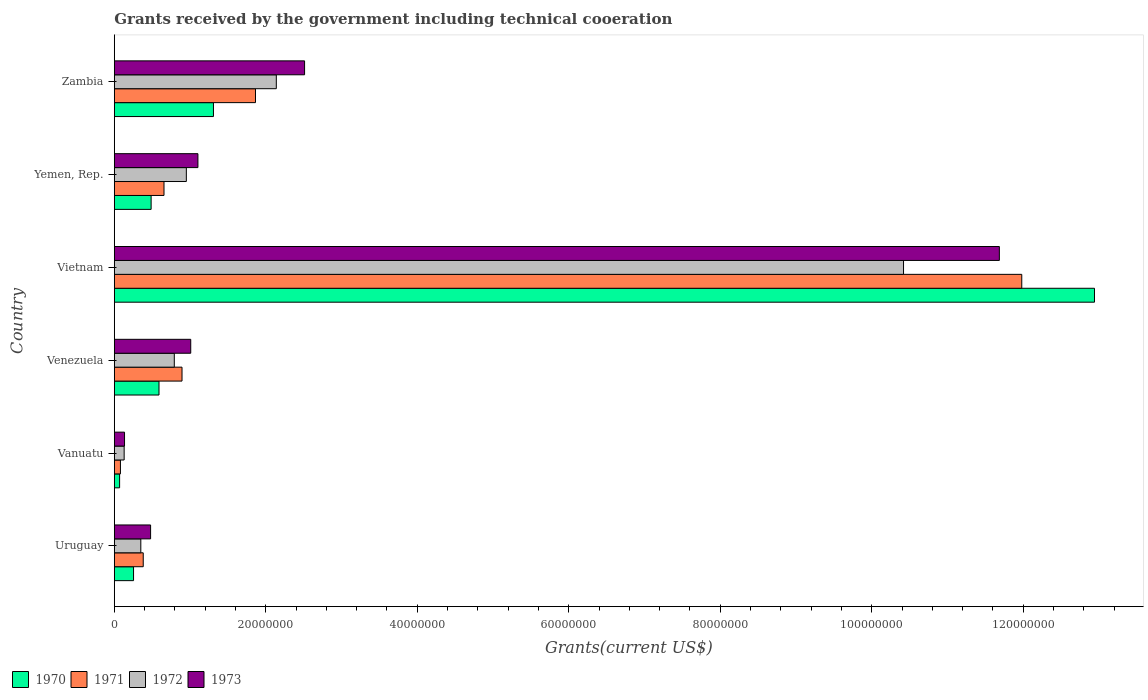How many groups of bars are there?
Your answer should be compact. 6. Are the number of bars per tick equal to the number of legend labels?
Offer a very short reply. Yes. What is the label of the 5th group of bars from the top?
Offer a terse response. Vanuatu. In how many cases, is the number of bars for a given country not equal to the number of legend labels?
Offer a very short reply. 0. What is the total grants received by the government in 1970 in Vanuatu?
Ensure brevity in your answer.  7.00e+05. Across all countries, what is the maximum total grants received by the government in 1973?
Provide a succinct answer. 1.17e+08. Across all countries, what is the minimum total grants received by the government in 1971?
Keep it short and to the point. 8.10e+05. In which country was the total grants received by the government in 1973 maximum?
Your answer should be very brief. Vietnam. In which country was the total grants received by the government in 1972 minimum?
Give a very brief answer. Vanuatu. What is the total total grants received by the government in 1973 in the graph?
Offer a terse response. 1.69e+08. What is the difference between the total grants received by the government in 1973 in Venezuela and that in Zambia?
Your response must be concise. -1.50e+07. What is the difference between the total grants received by the government in 1972 in Yemen, Rep. and the total grants received by the government in 1970 in Uruguay?
Your answer should be compact. 6.97e+06. What is the average total grants received by the government in 1970 per country?
Provide a short and direct response. 2.61e+07. What is the difference between the total grants received by the government in 1973 and total grants received by the government in 1970 in Zambia?
Ensure brevity in your answer.  1.20e+07. What is the ratio of the total grants received by the government in 1970 in Uruguay to that in Venezuela?
Offer a very short reply. 0.43. Is the total grants received by the government in 1970 in Vietnam less than that in Yemen, Rep.?
Give a very brief answer. No. What is the difference between the highest and the second highest total grants received by the government in 1970?
Your answer should be compact. 1.16e+08. What is the difference between the highest and the lowest total grants received by the government in 1972?
Provide a succinct answer. 1.03e+08. In how many countries, is the total grants received by the government in 1972 greater than the average total grants received by the government in 1972 taken over all countries?
Offer a very short reply. 1. Is it the case that in every country, the sum of the total grants received by the government in 1971 and total grants received by the government in 1972 is greater than the sum of total grants received by the government in 1970 and total grants received by the government in 1973?
Keep it short and to the point. No. What does the 2nd bar from the bottom in Yemen, Rep. represents?
Your response must be concise. 1971. Is it the case that in every country, the sum of the total grants received by the government in 1972 and total grants received by the government in 1971 is greater than the total grants received by the government in 1970?
Give a very brief answer. Yes. Are all the bars in the graph horizontal?
Your answer should be compact. Yes. How many countries are there in the graph?
Offer a terse response. 6. What is the difference between two consecutive major ticks on the X-axis?
Offer a terse response. 2.00e+07. Are the values on the major ticks of X-axis written in scientific E-notation?
Provide a succinct answer. No. Does the graph contain grids?
Keep it short and to the point. No. What is the title of the graph?
Ensure brevity in your answer.  Grants received by the government including technical cooeration. Does "2007" appear as one of the legend labels in the graph?
Provide a short and direct response. No. What is the label or title of the X-axis?
Make the answer very short. Grants(current US$). What is the Grants(current US$) in 1970 in Uruguay?
Your answer should be very brief. 2.54e+06. What is the Grants(current US$) of 1971 in Uruguay?
Provide a succinct answer. 3.82e+06. What is the Grants(current US$) in 1972 in Uruguay?
Your answer should be very brief. 3.50e+06. What is the Grants(current US$) in 1973 in Uruguay?
Provide a short and direct response. 4.79e+06. What is the Grants(current US$) in 1970 in Vanuatu?
Your answer should be compact. 7.00e+05. What is the Grants(current US$) of 1971 in Vanuatu?
Provide a succinct answer. 8.10e+05. What is the Grants(current US$) in 1972 in Vanuatu?
Your answer should be compact. 1.30e+06. What is the Grants(current US$) in 1973 in Vanuatu?
Give a very brief answer. 1.35e+06. What is the Grants(current US$) of 1970 in Venezuela?
Keep it short and to the point. 5.90e+06. What is the Grants(current US$) of 1971 in Venezuela?
Give a very brief answer. 8.94e+06. What is the Grants(current US$) of 1972 in Venezuela?
Keep it short and to the point. 7.92e+06. What is the Grants(current US$) in 1973 in Venezuela?
Offer a terse response. 1.01e+07. What is the Grants(current US$) of 1970 in Vietnam?
Keep it short and to the point. 1.29e+08. What is the Grants(current US$) of 1971 in Vietnam?
Provide a succinct answer. 1.20e+08. What is the Grants(current US$) in 1972 in Vietnam?
Your answer should be compact. 1.04e+08. What is the Grants(current US$) in 1973 in Vietnam?
Your answer should be compact. 1.17e+08. What is the Grants(current US$) of 1970 in Yemen, Rep.?
Your response must be concise. 4.86e+06. What is the Grants(current US$) of 1971 in Yemen, Rep.?
Ensure brevity in your answer.  6.56e+06. What is the Grants(current US$) in 1972 in Yemen, Rep.?
Your answer should be very brief. 9.51e+06. What is the Grants(current US$) of 1973 in Yemen, Rep.?
Keep it short and to the point. 1.10e+07. What is the Grants(current US$) of 1970 in Zambia?
Give a very brief answer. 1.31e+07. What is the Grants(current US$) of 1971 in Zambia?
Your response must be concise. 1.86e+07. What is the Grants(current US$) of 1972 in Zambia?
Make the answer very short. 2.14e+07. What is the Grants(current US$) of 1973 in Zambia?
Provide a succinct answer. 2.51e+07. Across all countries, what is the maximum Grants(current US$) of 1970?
Offer a very short reply. 1.29e+08. Across all countries, what is the maximum Grants(current US$) of 1971?
Your answer should be compact. 1.20e+08. Across all countries, what is the maximum Grants(current US$) of 1972?
Offer a terse response. 1.04e+08. Across all countries, what is the maximum Grants(current US$) of 1973?
Provide a succinct answer. 1.17e+08. Across all countries, what is the minimum Grants(current US$) of 1971?
Offer a terse response. 8.10e+05. Across all countries, what is the minimum Grants(current US$) in 1972?
Provide a succinct answer. 1.30e+06. Across all countries, what is the minimum Grants(current US$) in 1973?
Your response must be concise. 1.35e+06. What is the total Grants(current US$) of 1970 in the graph?
Your response must be concise. 1.56e+08. What is the total Grants(current US$) of 1971 in the graph?
Offer a very short reply. 1.59e+08. What is the total Grants(current US$) in 1972 in the graph?
Keep it short and to the point. 1.48e+08. What is the total Grants(current US$) of 1973 in the graph?
Ensure brevity in your answer.  1.69e+08. What is the difference between the Grants(current US$) of 1970 in Uruguay and that in Vanuatu?
Offer a very short reply. 1.84e+06. What is the difference between the Grants(current US$) of 1971 in Uruguay and that in Vanuatu?
Provide a short and direct response. 3.01e+06. What is the difference between the Grants(current US$) of 1972 in Uruguay and that in Vanuatu?
Provide a succinct answer. 2.20e+06. What is the difference between the Grants(current US$) in 1973 in Uruguay and that in Vanuatu?
Your answer should be very brief. 3.44e+06. What is the difference between the Grants(current US$) of 1970 in Uruguay and that in Venezuela?
Your answer should be very brief. -3.36e+06. What is the difference between the Grants(current US$) in 1971 in Uruguay and that in Venezuela?
Offer a very short reply. -5.12e+06. What is the difference between the Grants(current US$) of 1972 in Uruguay and that in Venezuela?
Provide a short and direct response. -4.42e+06. What is the difference between the Grants(current US$) in 1973 in Uruguay and that in Venezuela?
Ensure brevity in your answer.  -5.30e+06. What is the difference between the Grants(current US$) of 1970 in Uruguay and that in Vietnam?
Offer a terse response. -1.27e+08. What is the difference between the Grants(current US$) in 1971 in Uruguay and that in Vietnam?
Your response must be concise. -1.16e+08. What is the difference between the Grants(current US$) in 1972 in Uruguay and that in Vietnam?
Your answer should be compact. -1.01e+08. What is the difference between the Grants(current US$) of 1973 in Uruguay and that in Vietnam?
Keep it short and to the point. -1.12e+08. What is the difference between the Grants(current US$) in 1970 in Uruguay and that in Yemen, Rep.?
Make the answer very short. -2.32e+06. What is the difference between the Grants(current US$) of 1971 in Uruguay and that in Yemen, Rep.?
Keep it short and to the point. -2.74e+06. What is the difference between the Grants(current US$) of 1972 in Uruguay and that in Yemen, Rep.?
Ensure brevity in your answer.  -6.01e+06. What is the difference between the Grants(current US$) of 1973 in Uruguay and that in Yemen, Rep.?
Your answer should be compact. -6.25e+06. What is the difference between the Grants(current US$) in 1970 in Uruguay and that in Zambia?
Give a very brief answer. -1.06e+07. What is the difference between the Grants(current US$) of 1971 in Uruguay and that in Zambia?
Offer a terse response. -1.48e+07. What is the difference between the Grants(current US$) of 1972 in Uruguay and that in Zambia?
Offer a very short reply. -1.79e+07. What is the difference between the Grants(current US$) of 1973 in Uruguay and that in Zambia?
Your response must be concise. -2.03e+07. What is the difference between the Grants(current US$) in 1970 in Vanuatu and that in Venezuela?
Make the answer very short. -5.20e+06. What is the difference between the Grants(current US$) of 1971 in Vanuatu and that in Venezuela?
Provide a succinct answer. -8.13e+06. What is the difference between the Grants(current US$) of 1972 in Vanuatu and that in Venezuela?
Offer a very short reply. -6.62e+06. What is the difference between the Grants(current US$) of 1973 in Vanuatu and that in Venezuela?
Keep it short and to the point. -8.74e+06. What is the difference between the Grants(current US$) in 1970 in Vanuatu and that in Vietnam?
Keep it short and to the point. -1.29e+08. What is the difference between the Grants(current US$) of 1971 in Vanuatu and that in Vietnam?
Make the answer very short. -1.19e+08. What is the difference between the Grants(current US$) in 1972 in Vanuatu and that in Vietnam?
Provide a succinct answer. -1.03e+08. What is the difference between the Grants(current US$) in 1973 in Vanuatu and that in Vietnam?
Your response must be concise. -1.16e+08. What is the difference between the Grants(current US$) in 1970 in Vanuatu and that in Yemen, Rep.?
Your answer should be very brief. -4.16e+06. What is the difference between the Grants(current US$) of 1971 in Vanuatu and that in Yemen, Rep.?
Your answer should be very brief. -5.75e+06. What is the difference between the Grants(current US$) of 1972 in Vanuatu and that in Yemen, Rep.?
Make the answer very short. -8.21e+06. What is the difference between the Grants(current US$) of 1973 in Vanuatu and that in Yemen, Rep.?
Your response must be concise. -9.69e+06. What is the difference between the Grants(current US$) of 1970 in Vanuatu and that in Zambia?
Provide a succinct answer. -1.24e+07. What is the difference between the Grants(current US$) in 1971 in Vanuatu and that in Zambia?
Your answer should be very brief. -1.78e+07. What is the difference between the Grants(current US$) of 1972 in Vanuatu and that in Zambia?
Give a very brief answer. -2.01e+07. What is the difference between the Grants(current US$) of 1973 in Vanuatu and that in Zambia?
Provide a succinct answer. -2.38e+07. What is the difference between the Grants(current US$) of 1970 in Venezuela and that in Vietnam?
Provide a succinct answer. -1.24e+08. What is the difference between the Grants(current US$) of 1971 in Venezuela and that in Vietnam?
Make the answer very short. -1.11e+08. What is the difference between the Grants(current US$) in 1972 in Venezuela and that in Vietnam?
Provide a short and direct response. -9.63e+07. What is the difference between the Grants(current US$) of 1973 in Venezuela and that in Vietnam?
Your answer should be very brief. -1.07e+08. What is the difference between the Grants(current US$) of 1970 in Venezuela and that in Yemen, Rep.?
Offer a very short reply. 1.04e+06. What is the difference between the Grants(current US$) of 1971 in Venezuela and that in Yemen, Rep.?
Your answer should be very brief. 2.38e+06. What is the difference between the Grants(current US$) in 1972 in Venezuela and that in Yemen, Rep.?
Offer a very short reply. -1.59e+06. What is the difference between the Grants(current US$) in 1973 in Venezuela and that in Yemen, Rep.?
Keep it short and to the point. -9.50e+05. What is the difference between the Grants(current US$) in 1970 in Venezuela and that in Zambia?
Offer a very short reply. -7.19e+06. What is the difference between the Grants(current US$) of 1971 in Venezuela and that in Zambia?
Your answer should be very brief. -9.70e+06. What is the difference between the Grants(current US$) of 1972 in Venezuela and that in Zambia?
Your response must be concise. -1.35e+07. What is the difference between the Grants(current US$) of 1973 in Venezuela and that in Zambia?
Make the answer very short. -1.50e+07. What is the difference between the Grants(current US$) in 1970 in Vietnam and that in Yemen, Rep.?
Give a very brief answer. 1.25e+08. What is the difference between the Grants(current US$) of 1971 in Vietnam and that in Yemen, Rep.?
Give a very brief answer. 1.13e+08. What is the difference between the Grants(current US$) of 1972 in Vietnam and that in Yemen, Rep.?
Your answer should be compact. 9.47e+07. What is the difference between the Grants(current US$) in 1973 in Vietnam and that in Yemen, Rep.?
Offer a terse response. 1.06e+08. What is the difference between the Grants(current US$) of 1970 in Vietnam and that in Zambia?
Offer a very short reply. 1.16e+08. What is the difference between the Grants(current US$) in 1971 in Vietnam and that in Zambia?
Give a very brief answer. 1.01e+08. What is the difference between the Grants(current US$) of 1972 in Vietnam and that in Zambia?
Keep it short and to the point. 8.28e+07. What is the difference between the Grants(current US$) in 1973 in Vietnam and that in Zambia?
Offer a terse response. 9.17e+07. What is the difference between the Grants(current US$) of 1970 in Yemen, Rep. and that in Zambia?
Offer a terse response. -8.23e+06. What is the difference between the Grants(current US$) of 1971 in Yemen, Rep. and that in Zambia?
Offer a terse response. -1.21e+07. What is the difference between the Grants(current US$) of 1972 in Yemen, Rep. and that in Zambia?
Offer a terse response. -1.19e+07. What is the difference between the Grants(current US$) in 1973 in Yemen, Rep. and that in Zambia?
Your answer should be very brief. -1.41e+07. What is the difference between the Grants(current US$) in 1970 in Uruguay and the Grants(current US$) in 1971 in Vanuatu?
Offer a terse response. 1.73e+06. What is the difference between the Grants(current US$) in 1970 in Uruguay and the Grants(current US$) in 1972 in Vanuatu?
Provide a succinct answer. 1.24e+06. What is the difference between the Grants(current US$) in 1970 in Uruguay and the Grants(current US$) in 1973 in Vanuatu?
Your response must be concise. 1.19e+06. What is the difference between the Grants(current US$) in 1971 in Uruguay and the Grants(current US$) in 1972 in Vanuatu?
Provide a short and direct response. 2.52e+06. What is the difference between the Grants(current US$) in 1971 in Uruguay and the Grants(current US$) in 1973 in Vanuatu?
Provide a succinct answer. 2.47e+06. What is the difference between the Grants(current US$) in 1972 in Uruguay and the Grants(current US$) in 1973 in Vanuatu?
Give a very brief answer. 2.15e+06. What is the difference between the Grants(current US$) of 1970 in Uruguay and the Grants(current US$) of 1971 in Venezuela?
Provide a short and direct response. -6.40e+06. What is the difference between the Grants(current US$) of 1970 in Uruguay and the Grants(current US$) of 1972 in Venezuela?
Make the answer very short. -5.38e+06. What is the difference between the Grants(current US$) in 1970 in Uruguay and the Grants(current US$) in 1973 in Venezuela?
Your response must be concise. -7.55e+06. What is the difference between the Grants(current US$) in 1971 in Uruguay and the Grants(current US$) in 1972 in Venezuela?
Ensure brevity in your answer.  -4.10e+06. What is the difference between the Grants(current US$) in 1971 in Uruguay and the Grants(current US$) in 1973 in Venezuela?
Your answer should be compact. -6.27e+06. What is the difference between the Grants(current US$) in 1972 in Uruguay and the Grants(current US$) in 1973 in Venezuela?
Your answer should be compact. -6.59e+06. What is the difference between the Grants(current US$) of 1970 in Uruguay and the Grants(current US$) of 1971 in Vietnam?
Provide a short and direct response. -1.17e+08. What is the difference between the Grants(current US$) of 1970 in Uruguay and the Grants(current US$) of 1972 in Vietnam?
Give a very brief answer. -1.02e+08. What is the difference between the Grants(current US$) of 1970 in Uruguay and the Grants(current US$) of 1973 in Vietnam?
Offer a terse response. -1.14e+08. What is the difference between the Grants(current US$) of 1971 in Uruguay and the Grants(current US$) of 1972 in Vietnam?
Provide a succinct answer. -1.00e+08. What is the difference between the Grants(current US$) in 1971 in Uruguay and the Grants(current US$) in 1973 in Vietnam?
Your answer should be compact. -1.13e+08. What is the difference between the Grants(current US$) of 1972 in Uruguay and the Grants(current US$) of 1973 in Vietnam?
Offer a terse response. -1.13e+08. What is the difference between the Grants(current US$) of 1970 in Uruguay and the Grants(current US$) of 1971 in Yemen, Rep.?
Your response must be concise. -4.02e+06. What is the difference between the Grants(current US$) of 1970 in Uruguay and the Grants(current US$) of 1972 in Yemen, Rep.?
Offer a terse response. -6.97e+06. What is the difference between the Grants(current US$) in 1970 in Uruguay and the Grants(current US$) in 1973 in Yemen, Rep.?
Ensure brevity in your answer.  -8.50e+06. What is the difference between the Grants(current US$) in 1971 in Uruguay and the Grants(current US$) in 1972 in Yemen, Rep.?
Your answer should be very brief. -5.69e+06. What is the difference between the Grants(current US$) of 1971 in Uruguay and the Grants(current US$) of 1973 in Yemen, Rep.?
Make the answer very short. -7.22e+06. What is the difference between the Grants(current US$) of 1972 in Uruguay and the Grants(current US$) of 1973 in Yemen, Rep.?
Your answer should be very brief. -7.54e+06. What is the difference between the Grants(current US$) of 1970 in Uruguay and the Grants(current US$) of 1971 in Zambia?
Keep it short and to the point. -1.61e+07. What is the difference between the Grants(current US$) in 1970 in Uruguay and the Grants(current US$) in 1972 in Zambia?
Your answer should be very brief. -1.88e+07. What is the difference between the Grants(current US$) in 1970 in Uruguay and the Grants(current US$) in 1973 in Zambia?
Offer a terse response. -2.26e+07. What is the difference between the Grants(current US$) of 1971 in Uruguay and the Grants(current US$) of 1972 in Zambia?
Give a very brief answer. -1.76e+07. What is the difference between the Grants(current US$) in 1971 in Uruguay and the Grants(current US$) in 1973 in Zambia?
Give a very brief answer. -2.13e+07. What is the difference between the Grants(current US$) of 1972 in Uruguay and the Grants(current US$) of 1973 in Zambia?
Your answer should be very brief. -2.16e+07. What is the difference between the Grants(current US$) in 1970 in Vanuatu and the Grants(current US$) in 1971 in Venezuela?
Offer a very short reply. -8.24e+06. What is the difference between the Grants(current US$) of 1970 in Vanuatu and the Grants(current US$) of 1972 in Venezuela?
Offer a terse response. -7.22e+06. What is the difference between the Grants(current US$) in 1970 in Vanuatu and the Grants(current US$) in 1973 in Venezuela?
Ensure brevity in your answer.  -9.39e+06. What is the difference between the Grants(current US$) in 1971 in Vanuatu and the Grants(current US$) in 1972 in Venezuela?
Your response must be concise. -7.11e+06. What is the difference between the Grants(current US$) of 1971 in Vanuatu and the Grants(current US$) of 1973 in Venezuela?
Keep it short and to the point. -9.28e+06. What is the difference between the Grants(current US$) of 1972 in Vanuatu and the Grants(current US$) of 1973 in Venezuela?
Your answer should be compact. -8.79e+06. What is the difference between the Grants(current US$) in 1970 in Vanuatu and the Grants(current US$) in 1971 in Vietnam?
Your response must be concise. -1.19e+08. What is the difference between the Grants(current US$) of 1970 in Vanuatu and the Grants(current US$) of 1972 in Vietnam?
Give a very brief answer. -1.04e+08. What is the difference between the Grants(current US$) in 1970 in Vanuatu and the Grants(current US$) in 1973 in Vietnam?
Your answer should be very brief. -1.16e+08. What is the difference between the Grants(current US$) in 1971 in Vanuatu and the Grants(current US$) in 1972 in Vietnam?
Provide a short and direct response. -1.03e+08. What is the difference between the Grants(current US$) of 1971 in Vanuatu and the Grants(current US$) of 1973 in Vietnam?
Provide a short and direct response. -1.16e+08. What is the difference between the Grants(current US$) in 1972 in Vanuatu and the Grants(current US$) in 1973 in Vietnam?
Offer a very short reply. -1.16e+08. What is the difference between the Grants(current US$) in 1970 in Vanuatu and the Grants(current US$) in 1971 in Yemen, Rep.?
Your answer should be compact. -5.86e+06. What is the difference between the Grants(current US$) in 1970 in Vanuatu and the Grants(current US$) in 1972 in Yemen, Rep.?
Ensure brevity in your answer.  -8.81e+06. What is the difference between the Grants(current US$) of 1970 in Vanuatu and the Grants(current US$) of 1973 in Yemen, Rep.?
Offer a very short reply. -1.03e+07. What is the difference between the Grants(current US$) in 1971 in Vanuatu and the Grants(current US$) in 1972 in Yemen, Rep.?
Your answer should be compact. -8.70e+06. What is the difference between the Grants(current US$) of 1971 in Vanuatu and the Grants(current US$) of 1973 in Yemen, Rep.?
Your answer should be compact. -1.02e+07. What is the difference between the Grants(current US$) of 1972 in Vanuatu and the Grants(current US$) of 1973 in Yemen, Rep.?
Provide a succinct answer. -9.74e+06. What is the difference between the Grants(current US$) in 1970 in Vanuatu and the Grants(current US$) in 1971 in Zambia?
Ensure brevity in your answer.  -1.79e+07. What is the difference between the Grants(current US$) of 1970 in Vanuatu and the Grants(current US$) of 1972 in Zambia?
Provide a short and direct response. -2.07e+07. What is the difference between the Grants(current US$) in 1970 in Vanuatu and the Grants(current US$) in 1973 in Zambia?
Provide a short and direct response. -2.44e+07. What is the difference between the Grants(current US$) in 1971 in Vanuatu and the Grants(current US$) in 1972 in Zambia?
Provide a short and direct response. -2.06e+07. What is the difference between the Grants(current US$) in 1971 in Vanuatu and the Grants(current US$) in 1973 in Zambia?
Your answer should be compact. -2.43e+07. What is the difference between the Grants(current US$) in 1972 in Vanuatu and the Grants(current US$) in 1973 in Zambia?
Give a very brief answer. -2.38e+07. What is the difference between the Grants(current US$) of 1970 in Venezuela and the Grants(current US$) of 1971 in Vietnam?
Make the answer very short. -1.14e+08. What is the difference between the Grants(current US$) of 1970 in Venezuela and the Grants(current US$) of 1972 in Vietnam?
Your response must be concise. -9.83e+07. What is the difference between the Grants(current US$) in 1970 in Venezuela and the Grants(current US$) in 1973 in Vietnam?
Offer a terse response. -1.11e+08. What is the difference between the Grants(current US$) of 1971 in Venezuela and the Grants(current US$) of 1972 in Vietnam?
Keep it short and to the point. -9.53e+07. What is the difference between the Grants(current US$) of 1971 in Venezuela and the Grants(current US$) of 1973 in Vietnam?
Offer a terse response. -1.08e+08. What is the difference between the Grants(current US$) in 1972 in Venezuela and the Grants(current US$) in 1973 in Vietnam?
Your response must be concise. -1.09e+08. What is the difference between the Grants(current US$) of 1970 in Venezuela and the Grants(current US$) of 1971 in Yemen, Rep.?
Give a very brief answer. -6.60e+05. What is the difference between the Grants(current US$) in 1970 in Venezuela and the Grants(current US$) in 1972 in Yemen, Rep.?
Offer a terse response. -3.61e+06. What is the difference between the Grants(current US$) of 1970 in Venezuela and the Grants(current US$) of 1973 in Yemen, Rep.?
Offer a terse response. -5.14e+06. What is the difference between the Grants(current US$) in 1971 in Venezuela and the Grants(current US$) in 1972 in Yemen, Rep.?
Provide a succinct answer. -5.70e+05. What is the difference between the Grants(current US$) in 1971 in Venezuela and the Grants(current US$) in 1973 in Yemen, Rep.?
Your answer should be very brief. -2.10e+06. What is the difference between the Grants(current US$) of 1972 in Venezuela and the Grants(current US$) of 1973 in Yemen, Rep.?
Ensure brevity in your answer.  -3.12e+06. What is the difference between the Grants(current US$) in 1970 in Venezuela and the Grants(current US$) in 1971 in Zambia?
Give a very brief answer. -1.27e+07. What is the difference between the Grants(current US$) in 1970 in Venezuela and the Grants(current US$) in 1972 in Zambia?
Keep it short and to the point. -1.55e+07. What is the difference between the Grants(current US$) in 1970 in Venezuela and the Grants(current US$) in 1973 in Zambia?
Your answer should be very brief. -1.92e+07. What is the difference between the Grants(current US$) in 1971 in Venezuela and the Grants(current US$) in 1972 in Zambia?
Ensure brevity in your answer.  -1.24e+07. What is the difference between the Grants(current US$) in 1971 in Venezuela and the Grants(current US$) in 1973 in Zambia?
Make the answer very short. -1.62e+07. What is the difference between the Grants(current US$) of 1972 in Venezuela and the Grants(current US$) of 1973 in Zambia?
Keep it short and to the point. -1.72e+07. What is the difference between the Grants(current US$) in 1970 in Vietnam and the Grants(current US$) in 1971 in Yemen, Rep.?
Give a very brief answer. 1.23e+08. What is the difference between the Grants(current US$) of 1970 in Vietnam and the Grants(current US$) of 1972 in Yemen, Rep.?
Provide a short and direct response. 1.20e+08. What is the difference between the Grants(current US$) of 1970 in Vietnam and the Grants(current US$) of 1973 in Yemen, Rep.?
Provide a short and direct response. 1.18e+08. What is the difference between the Grants(current US$) in 1971 in Vietnam and the Grants(current US$) in 1972 in Yemen, Rep.?
Your answer should be very brief. 1.10e+08. What is the difference between the Grants(current US$) in 1971 in Vietnam and the Grants(current US$) in 1973 in Yemen, Rep.?
Give a very brief answer. 1.09e+08. What is the difference between the Grants(current US$) in 1972 in Vietnam and the Grants(current US$) in 1973 in Yemen, Rep.?
Ensure brevity in your answer.  9.32e+07. What is the difference between the Grants(current US$) of 1970 in Vietnam and the Grants(current US$) of 1971 in Zambia?
Provide a succinct answer. 1.11e+08. What is the difference between the Grants(current US$) in 1970 in Vietnam and the Grants(current US$) in 1972 in Zambia?
Give a very brief answer. 1.08e+08. What is the difference between the Grants(current US$) of 1970 in Vietnam and the Grants(current US$) of 1973 in Zambia?
Keep it short and to the point. 1.04e+08. What is the difference between the Grants(current US$) of 1971 in Vietnam and the Grants(current US$) of 1972 in Zambia?
Your answer should be very brief. 9.84e+07. What is the difference between the Grants(current US$) of 1971 in Vietnam and the Grants(current US$) of 1973 in Zambia?
Keep it short and to the point. 9.47e+07. What is the difference between the Grants(current US$) in 1972 in Vietnam and the Grants(current US$) in 1973 in Zambia?
Ensure brevity in your answer.  7.91e+07. What is the difference between the Grants(current US$) of 1970 in Yemen, Rep. and the Grants(current US$) of 1971 in Zambia?
Keep it short and to the point. -1.38e+07. What is the difference between the Grants(current US$) of 1970 in Yemen, Rep. and the Grants(current US$) of 1972 in Zambia?
Keep it short and to the point. -1.65e+07. What is the difference between the Grants(current US$) in 1970 in Yemen, Rep. and the Grants(current US$) in 1973 in Zambia?
Keep it short and to the point. -2.03e+07. What is the difference between the Grants(current US$) of 1971 in Yemen, Rep. and the Grants(current US$) of 1972 in Zambia?
Ensure brevity in your answer.  -1.48e+07. What is the difference between the Grants(current US$) of 1971 in Yemen, Rep. and the Grants(current US$) of 1973 in Zambia?
Offer a terse response. -1.86e+07. What is the difference between the Grants(current US$) of 1972 in Yemen, Rep. and the Grants(current US$) of 1973 in Zambia?
Your answer should be compact. -1.56e+07. What is the average Grants(current US$) in 1970 per country?
Your answer should be very brief. 2.61e+07. What is the average Grants(current US$) of 1971 per country?
Offer a very short reply. 2.64e+07. What is the average Grants(current US$) of 1972 per country?
Provide a short and direct response. 2.46e+07. What is the average Grants(current US$) of 1973 per country?
Your answer should be compact. 2.82e+07. What is the difference between the Grants(current US$) of 1970 and Grants(current US$) of 1971 in Uruguay?
Your answer should be very brief. -1.28e+06. What is the difference between the Grants(current US$) in 1970 and Grants(current US$) in 1972 in Uruguay?
Provide a short and direct response. -9.60e+05. What is the difference between the Grants(current US$) of 1970 and Grants(current US$) of 1973 in Uruguay?
Your response must be concise. -2.25e+06. What is the difference between the Grants(current US$) in 1971 and Grants(current US$) in 1973 in Uruguay?
Offer a terse response. -9.70e+05. What is the difference between the Grants(current US$) in 1972 and Grants(current US$) in 1973 in Uruguay?
Keep it short and to the point. -1.29e+06. What is the difference between the Grants(current US$) of 1970 and Grants(current US$) of 1971 in Vanuatu?
Make the answer very short. -1.10e+05. What is the difference between the Grants(current US$) of 1970 and Grants(current US$) of 1972 in Vanuatu?
Your response must be concise. -6.00e+05. What is the difference between the Grants(current US$) of 1970 and Grants(current US$) of 1973 in Vanuatu?
Offer a very short reply. -6.50e+05. What is the difference between the Grants(current US$) in 1971 and Grants(current US$) in 1972 in Vanuatu?
Provide a succinct answer. -4.90e+05. What is the difference between the Grants(current US$) in 1971 and Grants(current US$) in 1973 in Vanuatu?
Your response must be concise. -5.40e+05. What is the difference between the Grants(current US$) in 1970 and Grants(current US$) in 1971 in Venezuela?
Ensure brevity in your answer.  -3.04e+06. What is the difference between the Grants(current US$) in 1970 and Grants(current US$) in 1972 in Venezuela?
Ensure brevity in your answer.  -2.02e+06. What is the difference between the Grants(current US$) of 1970 and Grants(current US$) of 1973 in Venezuela?
Offer a terse response. -4.19e+06. What is the difference between the Grants(current US$) of 1971 and Grants(current US$) of 1972 in Venezuela?
Give a very brief answer. 1.02e+06. What is the difference between the Grants(current US$) of 1971 and Grants(current US$) of 1973 in Venezuela?
Make the answer very short. -1.15e+06. What is the difference between the Grants(current US$) of 1972 and Grants(current US$) of 1973 in Venezuela?
Your answer should be very brief. -2.17e+06. What is the difference between the Grants(current US$) of 1970 and Grants(current US$) of 1971 in Vietnam?
Offer a terse response. 9.60e+06. What is the difference between the Grants(current US$) of 1970 and Grants(current US$) of 1972 in Vietnam?
Make the answer very short. 2.52e+07. What is the difference between the Grants(current US$) in 1970 and Grants(current US$) in 1973 in Vietnam?
Ensure brevity in your answer.  1.26e+07. What is the difference between the Grants(current US$) of 1971 and Grants(current US$) of 1972 in Vietnam?
Ensure brevity in your answer.  1.56e+07. What is the difference between the Grants(current US$) in 1971 and Grants(current US$) in 1973 in Vietnam?
Offer a very short reply. 2.96e+06. What is the difference between the Grants(current US$) of 1972 and Grants(current US$) of 1973 in Vietnam?
Your answer should be very brief. -1.26e+07. What is the difference between the Grants(current US$) in 1970 and Grants(current US$) in 1971 in Yemen, Rep.?
Your answer should be compact. -1.70e+06. What is the difference between the Grants(current US$) in 1970 and Grants(current US$) in 1972 in Yemen, Rep.?
Make the answer very short. -4.65e+06. What is the difference between the Grants(current US$) of 1970 and Grants(current US$) of 1973 in Yemen, Rep.?
Make the answer very short. -6.18e+06. What is the difference between the Grants(current US$) of 1971 and Grants(current US$) of 1972 in Yemen, Rep.?
Provide a succinct answer. -2.95e+06. What is the difference between the Grants(current US$) of 1971 and Grants(current US$) of 1973 in Yemen, Rep.?
Keep it short and to the point. -4.48e+06. What is the difference between the Grants(current US$) of 1972 and Grants(current US$) of 1973 in Yemen, Rep.?
Keep it short and to the point. -1.53e+06. What is the difference between the Grants(current US$) of 1970 and Grants(current US$) of 1971 in Zambia?
Ensure brevity in your answer.  -5.55e+06. What is the difference between the Grants(current US$) of 1970 and Grants(current US$) of 1972 in Zambia?
Give a very brief answer. -8.30e+06. What is the difference between the Grants(current US$) in 1970 and Grants(current US$) in 1973 in Zambia?
Your response must be concise. -1.20e+07. What is the difference between the Grants(current US$) of 1971 and Grants(current US$) of 1972 in Zambia?
Provide a short and direct response. -2.75e+06. What is the difference between the Grants(current US$) of 1971 and Grants(current US$) of 1973 in Zambia?
Keep it short and to the point. -6.48e+06. What is the difference between the Grants(current US$) in 1972 and Grants(current US$) in 1973 in Zambia?
Give a very brief answer. -3.73e+06. What is the ratio of the Grants(current US$) in 1970 in Uruguay to that in Vanuatu?
Your response must be concise. 3.63. What is the ratio of the Grants(current US$) in 1971 in Uruguay to that in Vanuatu?
Offer a terse response. 4.72. What is the ratio of the Grants(current US$) of 1972 in Uruguay to that in Vanuatu?
Keep it short and to the point. 2.69. What is the ratio of the Grants(current US$) in 1973 in Uruguay to that in Vanuatu?
Make the answer very short. 3.55. What is the ratio of the Grants(current US$) of 1970 in Uruguay to that in Venezuela?
Provide a short and direct response. 0.43. What is the ratio of the Grants(current US$) of 1971 in Uruguay to that in Venezuela?
Keep it short and to the point. 0.43. What is the ratio of the Grants(current US$) of 1972 in Uruguay to that in Venezuela?
Your answer should be very brief. 0.44. What is the ratio of the Grants(current US$) of 1973 in Uruguay to that in Venezuela?
Provide a succinct answer. 0.47. What is the ratio of the Grants(current US$) in 1970 in Uruguay to that in Vietnam?
Ensure brevity in your answer.  0.02. What is the ratio of the Grants(current US$) in 1971 in Uruguay to that in Vietnam?
Offer a terse response. 0.03. What is the ratio of the Grants(current US$) of 1972 in Uruguay to that in Vietnam?
Your answer should be compact. 0.03. What is the ratio of the Grants(current US$) in 1973 in Uruguay to that in Vietnam?
Your response must be concise. 0.04. What is the ratio of the Grants(current US$) of 1970 in Uruguay to that in Yemen, Rep.?
Provide a succinct answer. 0.52. What is the ratio of the Grants(current US$) in 1971 in Uruguay to that in Yemen, Rep.?
Provide a succinct answer. 0.58. What is the ratio of the Grants(current US$) of 1972 in Uruguay to that in Yemen, Rep.?
Your response must be concise. 0.37. What is the ratio of the Grants(current US$) of 1973 in Uruguay to that in Yemen, Rep.?
Your answer should be very brief. 0.43. What is the ratio of the Grants(current US$) in 1970 in Uruguay to that in Zambia?
Keep it short and to the point. 0.19. What is the ratio of the Grants(current US$) in 1971 in Uruguay to that in Zambia?
Offer a terse response. 0.2. What is the ratio of the Grants(current US$) in 1972 in Uruguay to that in Zambia?
Provide a short and direct response. 0.16. What is the ratio of the Grants(current US$) in 1973 in Uruguay to that in Zambia?
Ensure brevity in your answer.  0.19. What is the ratio of the Grants(current US$) of 1970 in Vanuatu to that in Venezuela?
Provide a short and direct response. 0.12. What is the ratio of the Grants(current US$) in 1971 in Vanuatu to that in Venezuela?
Offer a very short reply. 0.09. What is the ratio of the Grants(current US$) in 1972 in Vanuatu to that in Venezuela?
Provide a succinct answer. 0.16. What is the ratio of the Grants(current US$) in 1973 in Vanuatu to that in Venezuela?
Give a very brief answer. 0.13. What is the ratio of the Grants(current US$) of 1970 in Vanuatu to that in Vietnam?
Offer a very short reply. 0.01. What is the ratio of the Grants(current US$) of 1971 in Vanuatu to that in Vietnam?
Offer a very short reply. 0.01. What is the ratio of the Grants(current US$) in 1972 in Vanuatu to that in Vietnam?
Give a very brief answer. 0.01. What is the ratio of the Grants(current US$) of 1973 in Vanuatu to that in Vietnam?
Offer a very short reply. 0.01. What is the ratio of the Grants(current US$) of 1970 in Vanuatu to that in Yemen, Rep.?
Offer a very short reply. 0.14. What is the ratio of the Grants(current US$) of 1971 in Vanuatu to that in Yemen, Rep.?
Keep it short and to the point. 0.12. What is the ratio of the Grants(current US$) of 1972 in Vanuatu to that in Yemen, Rep.?
Make the answer very short. 0.14. What is the ratio of the Grants(current US$) in 1973 in Vanuatu to that in Yemen, Rep.?
Your answer should be compact. 0.12. What is the ratio of the Grants(current US$) in 1970 in Vanuatu to that in Zambia?
Provide a short and direct response. 0.05. What is the ratio of the Grants(current US$) in 1971 in Vanuatu to that in Zambia?
Offer a terse response. 0.04. What is the ratio of the Grants(current US$) in 1972 in Vanuatu to that in Zambia?
Provide a short and direct response. 0.06. What is the ratio of the Grants(current US$) in 1973 in Vanuatu to that in Zambia?
Offer a very short reply. 0.05. What is the ratio of the Grants(current US$) of 1970 in Venezuela to that in Vietnam?
Provide a short and direct response. 0.05. What is the ratio of the Grants(current US$) in 1971 in Venezuela to that in Vietnam?
Your answer should be very brief. 0.07. What is the ratio of the Grants(current US$) in 1972 in Venezuela to that in Vietnam?
Make the answer very short. 0.08. What is the ratio of the Grants(current US$) of 1973 in Venezuela to that in Vietnam?
Your answer should be very brief. 0.09. What is the ratio of the Grants(current US$) in 1970 in Venezuela to that in Yemen, Rep.?
Ensure brevity in your answer.  1.21. What is the ratio of the Grants(current US$) in 1971 in Venezuela to that in Yemen, Rep.?
Offer a very short reply. 1.36. What is the ratio of the Grants(current US$) in 1972 in Venezuela to that in Yemen, Rep.?
Give a very brief answer. 0.83. What is the ratio of the Grants(current US$) in 1973 in Venezuela to that in Yemen, Rep.?
Your answer should be very brief. 0.91. What is the ratio of the Grants(current US$) of 1970 in Venezuela to that in Zambia?
Your answer should be very brief. 0.45. What is the ratio of the Grants(current US$) in 1971 in Venezuela to that in Zambia?
Make the answer very short. 0.48. What is the ratio of the Grants(current US$) in 1972 in Venezuela to that in Zambia?
Offer a very short reply. 0.37. What is the ratio of the Grants(current US$) of 1973 in Venezuela to that in Zambia?
Provide a short and direct response. 0.4. What is the ratio of the Grants(current US$) of 1970 in Vietnam to that in Yemen, Rep.?
Your response must be concise. 26.63. What is the ratio of the Grants(current US$) in 1971 in Vietnam to that in Yemen, Rep.?
Keep it short and to the point. 18.26. What is the ratio of the Grants(current US$) in 1972 in Vietnam to that in Yemen, Rep.?
Provide a short and direct response. 10.96. What is the ratio of the Grants(current US$) of 1973 in Vietnam to that in Yemen, Rep.?
Ensure brevity in your answer.  10.58. What is the ratio of the Grants(current US$) of 1970 in Vietnam to that in Zambia?
Ensure brevity in your answer.  9.89. What is the ratio of the Grants(current US$) of 1971 in Vietnam to that in Zambia?
Keep it short and to the point. 6.43. What is the ratio of the Grants(current US$) of 1972 in Vietnam to that in Zambia?
Provide a short and direct response. 4.87. What is the ratio of the Grants(current US$) in 1973 in Vietnam to that in Zambia?
Offer a very short reply. 4.65. What is the ratio of the Grants(current US$) in 1970 in Yemen, Rep. to that in Zambia?
Offer a terse response. 0.37. What is the ratio of the Grants(current US$) in 1971 in Yemen, Rep. to that in Zambia?
Give a very brief answer. 0.35. What is the ratio of the Grants(current US$) in 1972 in Yemen, Rep. to that in Zambia?
Your answer should be very brief. 0.44. What is the ratio of the Grants(current US$) of 1973 in Yemen, Rep. to that in Zambia?
Your response must be concise. 0.44. What is the difference between the highest and the second highest Grants(current US$) of 1970?
Offer a very short reply. 1.16e+08. What is the difference between the highest and the second highest Grants(current US$) in 1971?
Offer a very short reply. 1.01e+08. What is the difference between the highest and the second highest Grants(current US$) in 1972?
Your answer should be very brief. 8.28e+07. What is the difference between the highest and the second highest Grants(current US$) in 1973?
Give a very brief answer. 9.17e+07. What is the difference between the highest and the lowest Grants(current US$) of 1970?
Ensure brevity in your answer.  1.29e+08. What is the difference between the highest and the lowest Grants(current US$) of 1971?
Your answer should be compact. 1.19e+08. What is the difference between the highest and the lowest Grants(current US$) of 1972?
Your answer should be compact. 1.03e+08. What is the difference between the highest and the lowest Grants(current US$) in 1973?
Give a very brief answer. 1.16e+08. 